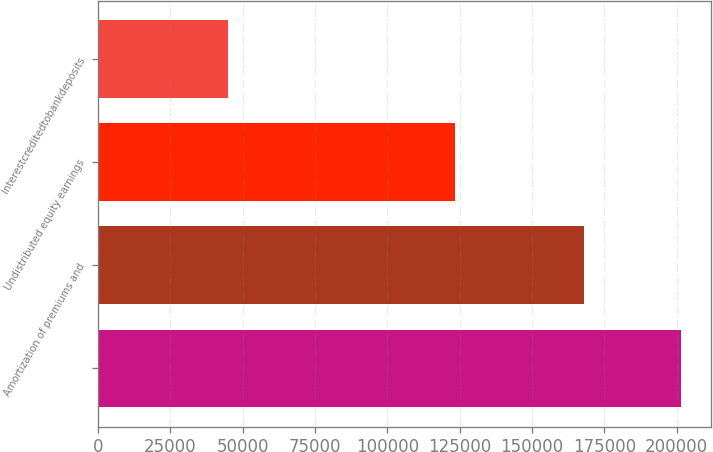Convert chart. <chart><loc_0><loc_0><loc_500><loc_500><bar_chart><ecel><fcel>Amortization of premiums and<fcel>Undistributed equity earnings<fcel>Interestcreditedtobankdeposits<nl><fcel>201671<fcel>168068<fcel>123263<fcel>44855.4<nl></chart> 